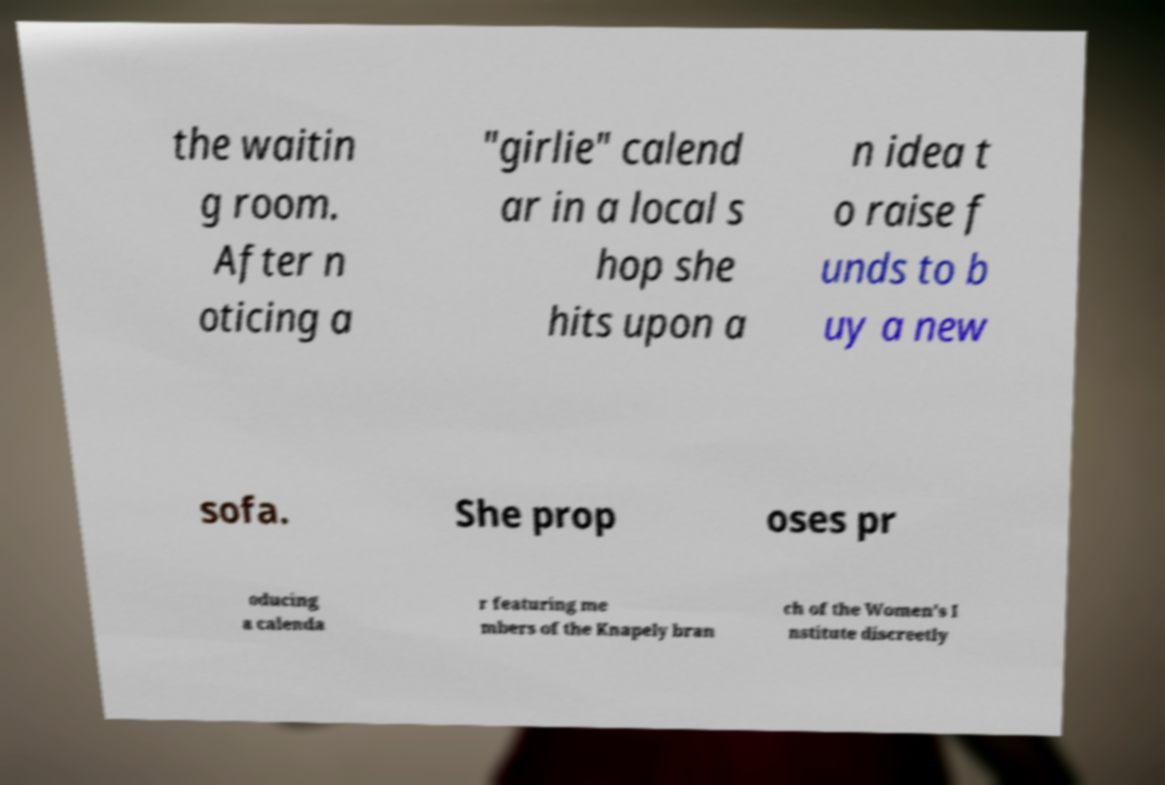Please identify and transcribe the text found in this image. the waitin g room. After n oticing a "girlie" calend ar in a local s hop she hits upon a n idea t o raise f unds to b uy a new sofa. She prop oses pr oducing a calenda r featuring me mbers of the Knapely bran ch of the Women's I nstitute discreetly 